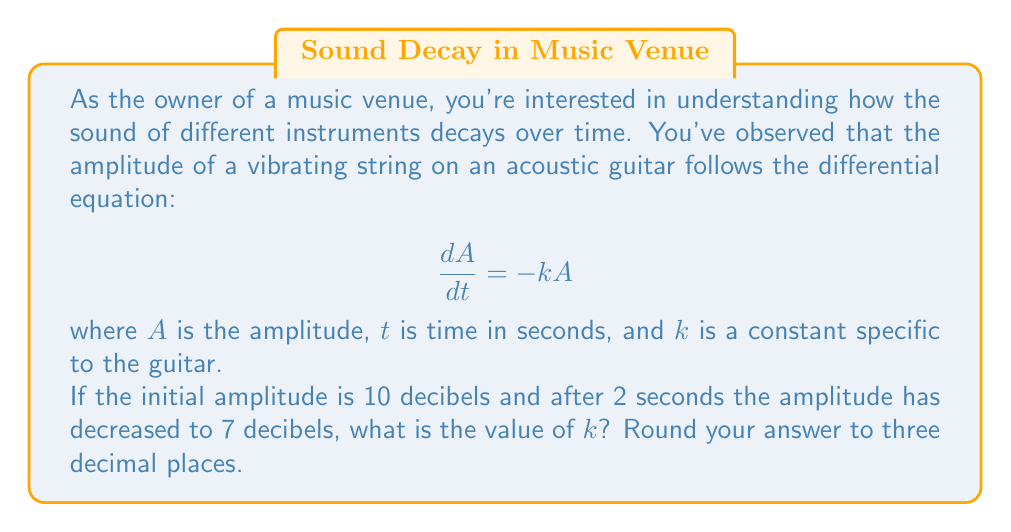Can you solve this math problem? Let's approach this step-by-step:

1) The given differential equation is a first-order separable equation. Its general solution is:

   $$A = A_0e^{-kt}$$

   where $A_0$ is the initial amplitude.

2) We're given two points:
   - At $t = 0$, $A = 10$ decibels
   - At $t = 2$, $A = 7$ decibels

3) Let's use these points in our general solution:

   For $t = 0$: $10 = A_0e^{-k(0)} = A_0$
   For $t = 2$: $7 = 10e^{-k(2)}$

4) Now we can solve for $k$:

   $$7 = 10e^{-2k}$$
   $$\frac{7}{10} = e^{-2k}$$
   $$\ln(\frac{7}{10}) = -2k$$
   $$k = -\frac{1}{2}\ln(\frac{7}{10})$$

5) Calculate the value:
   
   $$k = -\frac{1}{2}\ln(0.7) = 0.17889$$

6) Rounding to three decimal places:

   $$k \approx 0.179$$
Answer: $k \approx 0.179$ 